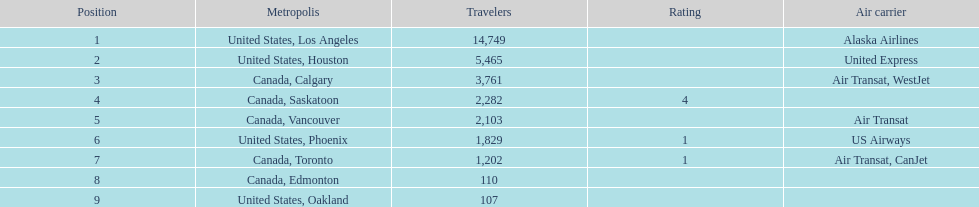Help me parse the entirety of this table. {'header': ['Position', 'Metropolis', 'Travelers', 'Rating', 'Air carrier'], 'rows': [['1', 'United States, Los Angeles', '14,749', '', 'Alaska Airlines'], ['2', 'United States, Houston', '5,465', '', 'United Express'], ['3', 'Canada, Calgary', '3,761', '', 'Air Transat, WestJet'], ['4', 'Canada, Saskatoon', '2,282', '4', ''], ['5', 'Canada, Vancouver', '2,103', '', 'Air Transat'], ['6', 'United States, Phoenix', '1,829', '1', 'US Airways'], ['7', 'Canada, Toronto', '1,202', '1', 'Air Transat, CanJet'], ['8', 'Canada, Edmonton', '110', '', ''], ['9', 'United States, Oakland', '107', '', '']]} The difference in passengers between los angeles and toronto 13,547. 